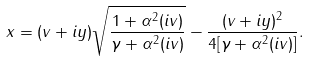Convert formula to latex. <formula><loc_0><loc_0><loc_500><loc_500>x = ( v + i y ) \sqrt { \frac { 1 + \alpha ^ { 2 } ( i v ) } { \gamma + \alpha ^ { 2 } ( i v ) } } - \frac { ( v + i y ) ^ { 2 } } { 4 [ \gamma + \alpha ^ { 2 } ( i v ) ] } .</formula> 